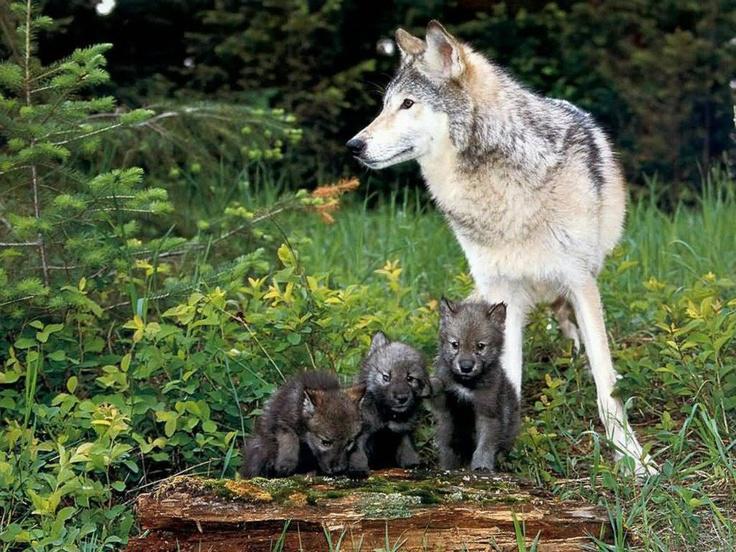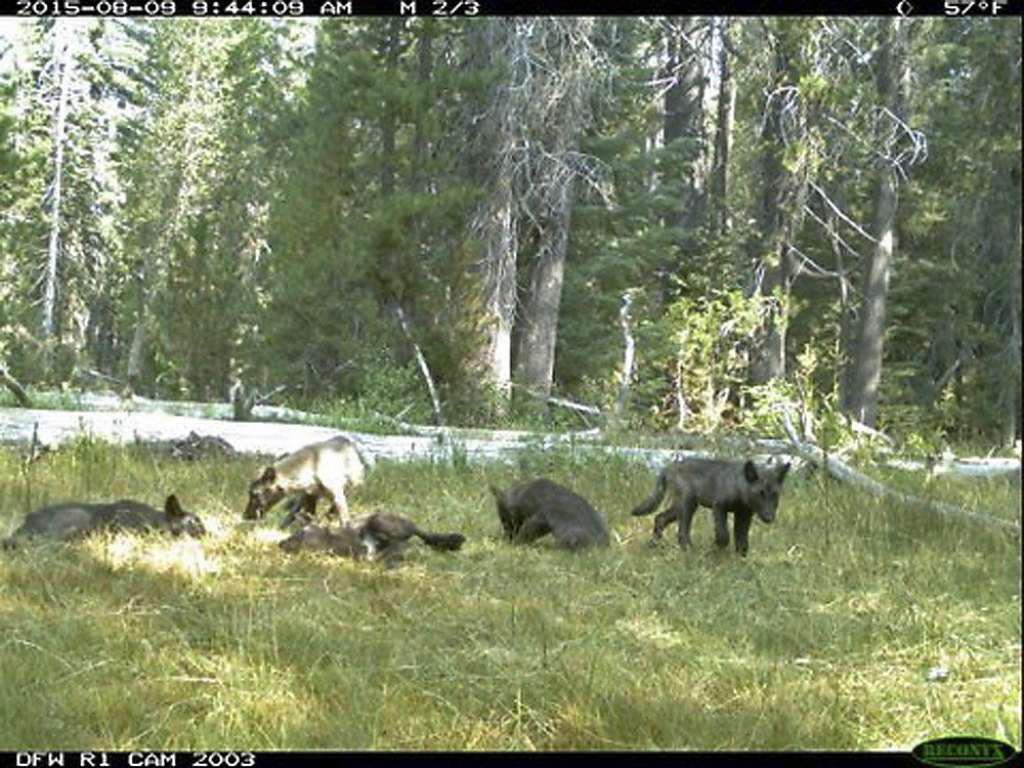The first image is the image on the left, the second image is the image on the right. Evaluate the accuracy of this statement regarding the images: "The left image contains exactly one wolf.". Is it true? Answer yes or no. No. The first image is the image on the left, the second image is the image on the right. Given the left and right images, does the statement "There is only one wolf in at least one of the images." hold true? Answer yes or no. No. 